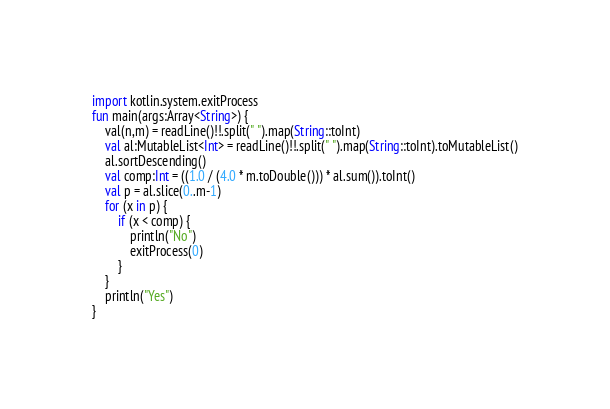Convert code to text. <code><loc_0><loc_0><loc_500><loc_500><_Kotlin_>import kotlin.system.exitProcess
fun main(args:Array<String>) {
    val(n,m) = readLine()!!.split(" ").map(String::toInt)
    val al:MutableList<Int> = readLine()!!.split(" ").map(String::toInt).toMutableList()
    al.sortDescending()
    val comp:Int = ((1.0 / (4.0 * m.toDouble())) * al.sum()).toInt()
    val p = al.slice(0..m-1)
    for (x in p) {
        if (x < comp) {
            println("No")
            exitProcess(0)
        }
    }
    println("Yes")
}
</code> 